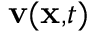<formula> <loc_0><loc_0><loc_500><loc_500>v ( x , t )</formula> 